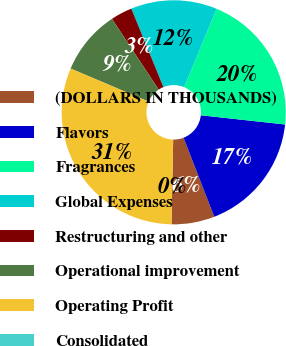<chart> <loc_0><loc_0><loc_500><loc_500><pie_chart><fcel>(DOLLARS IN THOUSANDS)<fcel>Flavors<fcel>Fragrances<fcel>Global Expenses<fcel>Restructuring and other<fcel>Operational improvement<fcel>Operating Profit<fcel>Consolidated<nl><fcel>6.21%<fcel>17.38%<fcel>20.48%<fcel>12.43%<fcel>3.11%<fcel>9.32%<fcel>31.07%<fcel>0.0%<nl></chart> 